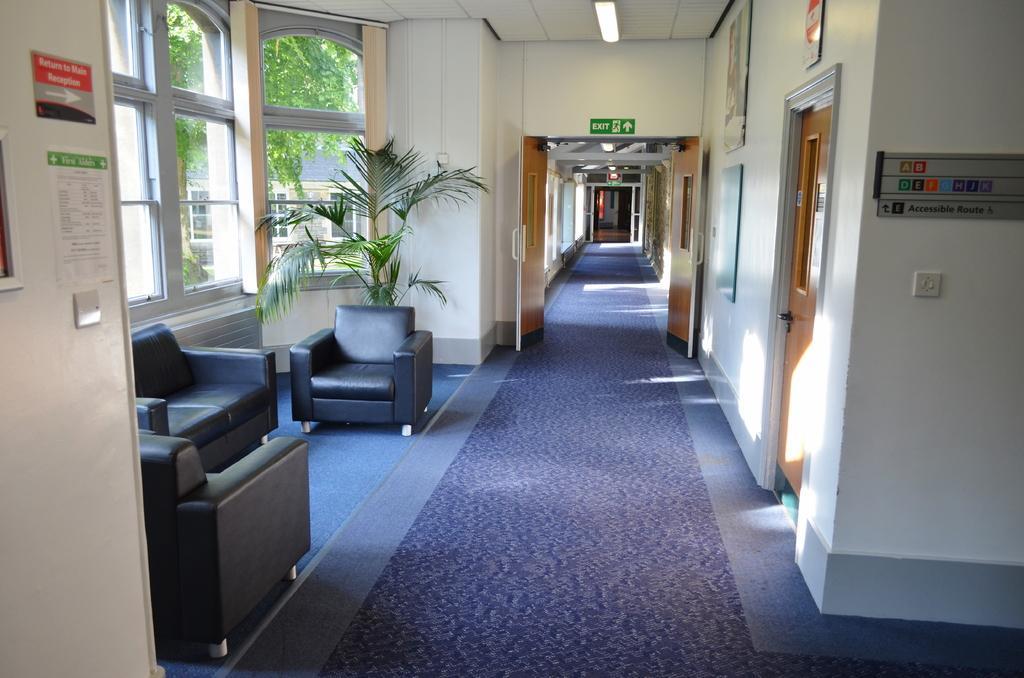Describe this image in one or two sentences. This is a building in which sofas,chairs,houseplants are there. Through window we can see tree and a building. 